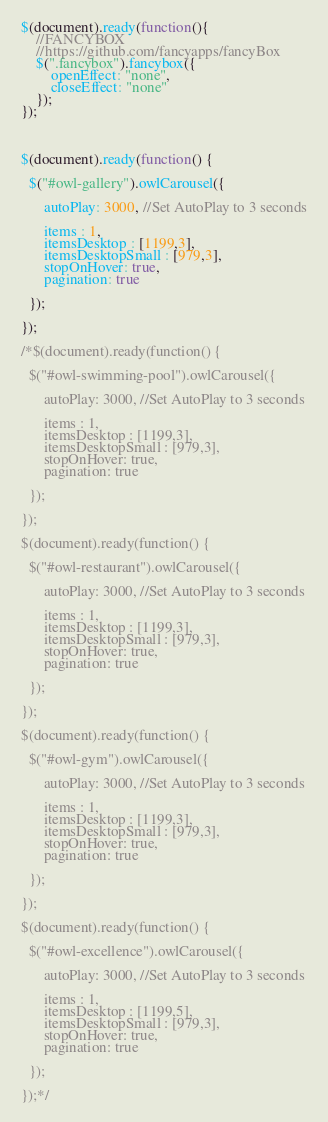Convert code to text. <code><loc_0><loc_0><loc_500><loc_500><_JavaScript_>$(document).ready(function(){
    //FANCYBOX
    //https://github.com/fancyapps/fancyBox
    $(".fancybox").fancybox({
        openEffect: "none",
        closeEffect: "none"
    });
});



$(document).ready(function() {
 
  $("#owl-gallery").owlCarousel({
 
      autoPlay: 3000, //Set AutoPlay to 3 seconds
 
      items : 1,
      itemsDesktop : [1199,3],
      itemsDesktopSmall : [979,3],
      stopOnHover: true,
      pagination: true
 
  });
 
});

/*$(document).ready(function() {
 
  $("#owl-swimming-pool").owlCarousel({
 
      autoPlay: 3000, //Set AutoPlay to 3 seconds
 
      items : 1,
      itemsDesktop : [1199,3],
      itemsDesktopSmall : [979,3],
      stopOnHover: true,
      pagination: true
 
  });
 
});

$(document).ready(function() {
 
  $("#owl-restaurant").owlCarousel({
 
      autoPlay: 3000, //Set AutoPlay to 3 seconds
 
      items : 1,
      itemsDesktop : [1199,3],
      itemsDesktopSmall : [979,3],
      stopOnHover: true,
      pagination: true
 
  });
 
});

$(document).ready(function() {
 
  $("#owl-gym").owlCarousel({
 
      autoPlay: 3000, //Set AutoPlay to 3 seconds
 
      items : 1,
      itemsDesktop : [1199,3],
      itemsDesktopSmall : [979,3],
      stopOnHover: true,
      pagination: true
 
  });
 
});

$(document).ready(function() {
 
  $("#owl-excellence").owlCarousel({
 
      autoPlay: 3000, //Set AutoPlay to 3 seconds
 
      items : 1,
      itemsDesktop : [1199,5],
      itemsDesktopSmall : [979,3],
      stopOnHover: true,
      pagination: true
 
  });
 
});*/</code> 